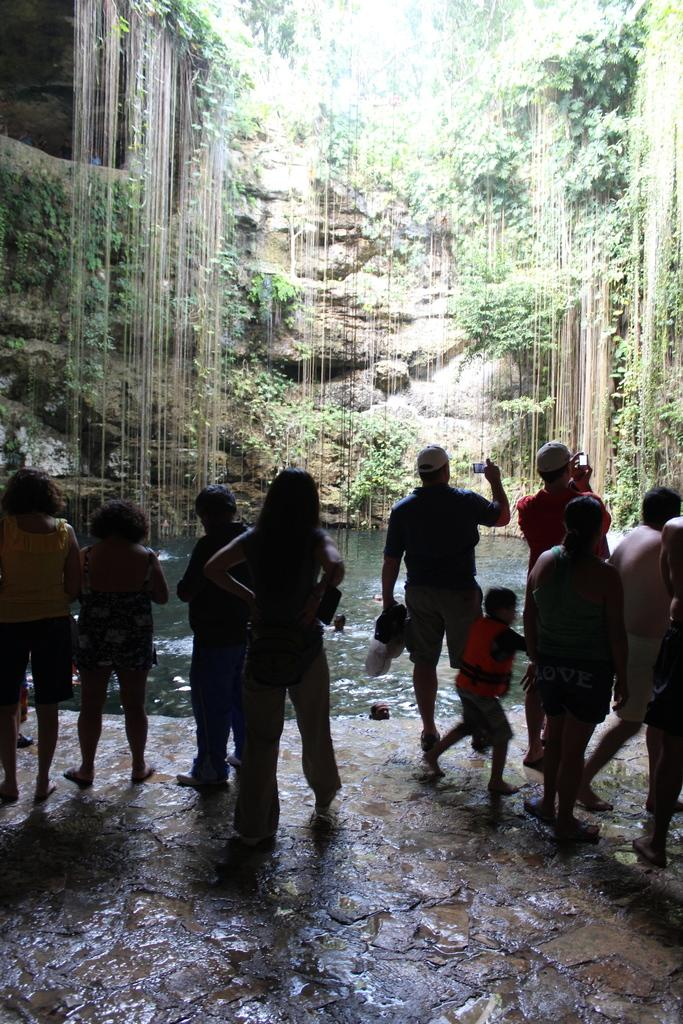How many people are in the image? There is a group of people in the image, but the exact number cannot be determined from the provided facts. What is the position of the people in the image? The people are on the ground in the image. What can be seen in the background of the image? There is water, rocks, and plants visible in the background of the image. What type of poison is being used by the people in the image? There is no indication of any poison or poisonous activity in the image; the people are simply on the ground. 